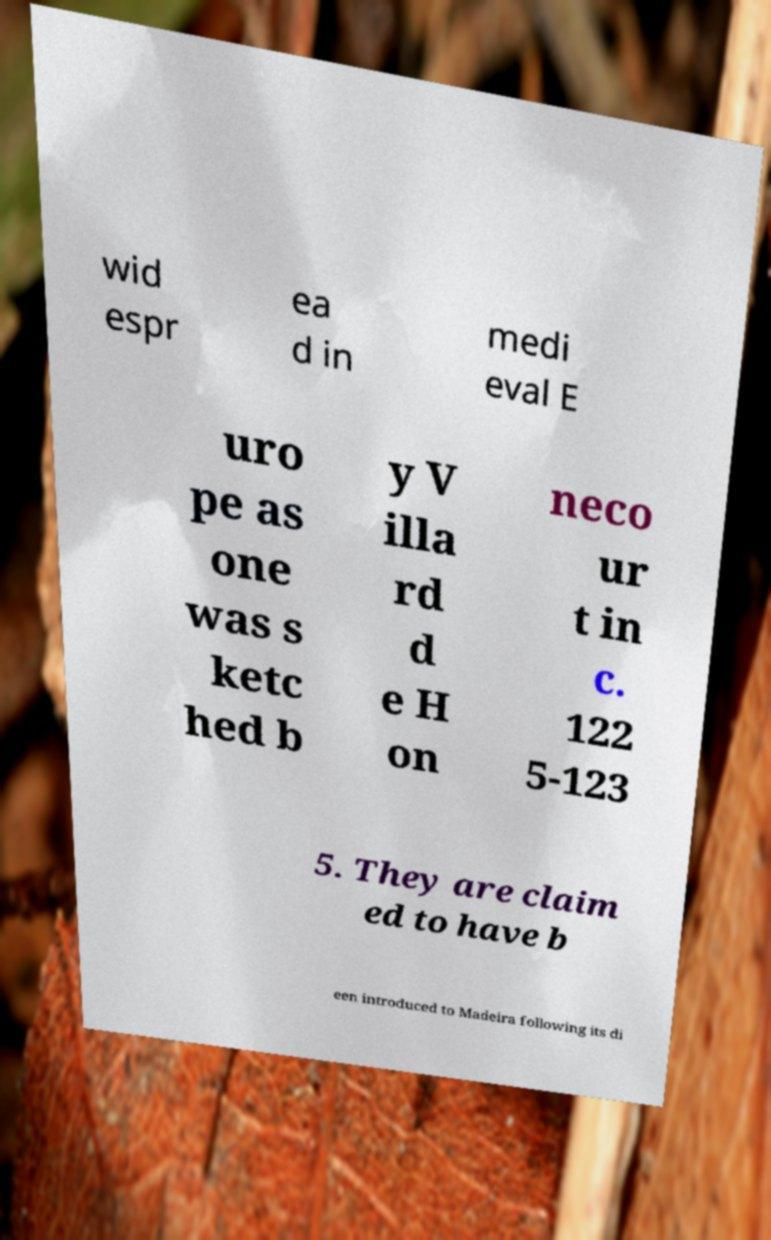What messages or text are displayed in this image? I need them in a readable, typed format. wid espr ea d in medi eval E uro pe as one was s ketc hed b y V illa rd d e H on neco ur t in c. 122 5-123 5. They are claim ed to have b een introduced to Madeira following its di 